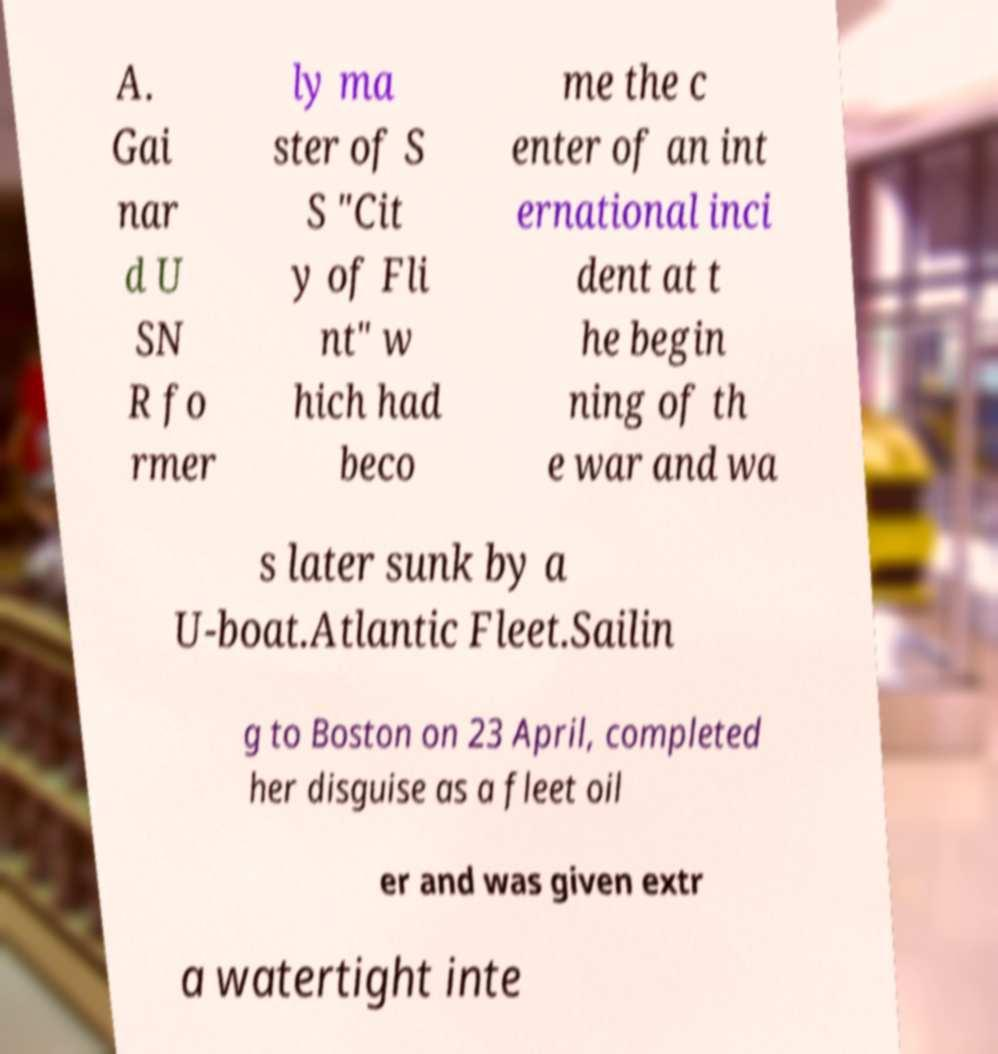Could you assist in decoding the text presented in this image and type it out clearly? A. Gai nar d U SN R fo rmer ly ma ster of S S "Cit y of Fli nt" w hich had beco me the c enter of an int ernational inci dent at t he begin ning of th e war and wa s later sunk by a U-boat.Atlantic Fleet.Sailin g to Boston on 23 April, completed her disguise as a fleet oil er and was given extr a watertight inte 